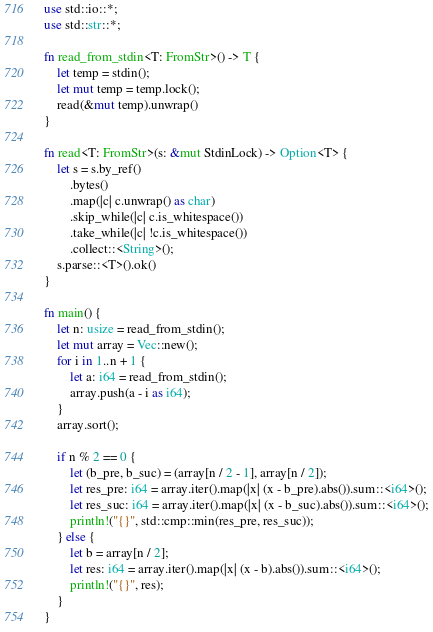<code> <loc_0><loc_0><loc_500><loc_500><_Rust_>use std::io::*;
use std::str::*;

fn read_from_stdin<T: FromStr>() -> T {
    let temp = stdin();
    let mut temp = temp.lock();
    read(&mut temp).unwrap()
}

fn read<T: FromStr>(s: &mut StdinLock) -> Option<T> {
    let s = s.by_ref()
        .bytes()
        .map(|c| c.unwrap() as char)
        .skip_while(|c| c.is_whitespace())
        .take_while(|c| !c.is_whitespace())
        .collect::<String>();
    s.parse::<T>().ok()
}

fn main() {
    let n: usize = read_from_stdin();
    let mut array = Vec::new();
    for i in 1..n + 1 {
        let a: i64 = read_from_stdin();
        array.push(a - i as i64);
    }
    array.sort();

    if n % 2 == 0 {
        let (b_pre, b_suc) = (array[n / 2 - 1], array[n / 2]);
        let res_pre: i64 = array.iter().map(|x| (x - b_pre).abs()).sum::<i64>();
        let res_suc: i64 = array.iter().map(|x| (x - b_suc).abs()).sum::<i64>();
        println!("{}", std::cmp::min(res_pre, res_suc));
    } else {
        let b = array[n / 2];
        let res: i64 = array.iter().map(|x| (x - b).abs()).sum::<i64>();
        println!("{}", res);
    }
}
</code> 